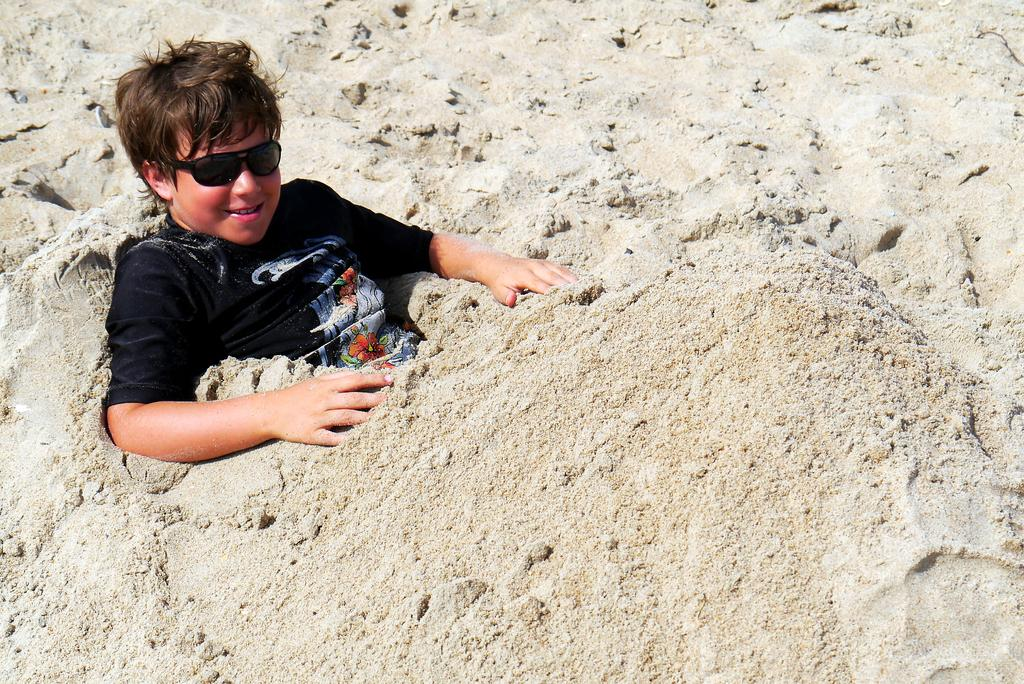Who is the main subject in the image? There is a boy in the image. What is the boy doing in the image? The boy is sitting in the sand. What is the boy wearing in the image? The boy is wearing a black T-shirt and black shades. What type of surface is visible at the bottom of the image? There is sand at the bottom of the image. What type of scale can be seen in the image? There is no scale present in the image. How many stars are visible in the image? There are no stars visible in the image. 